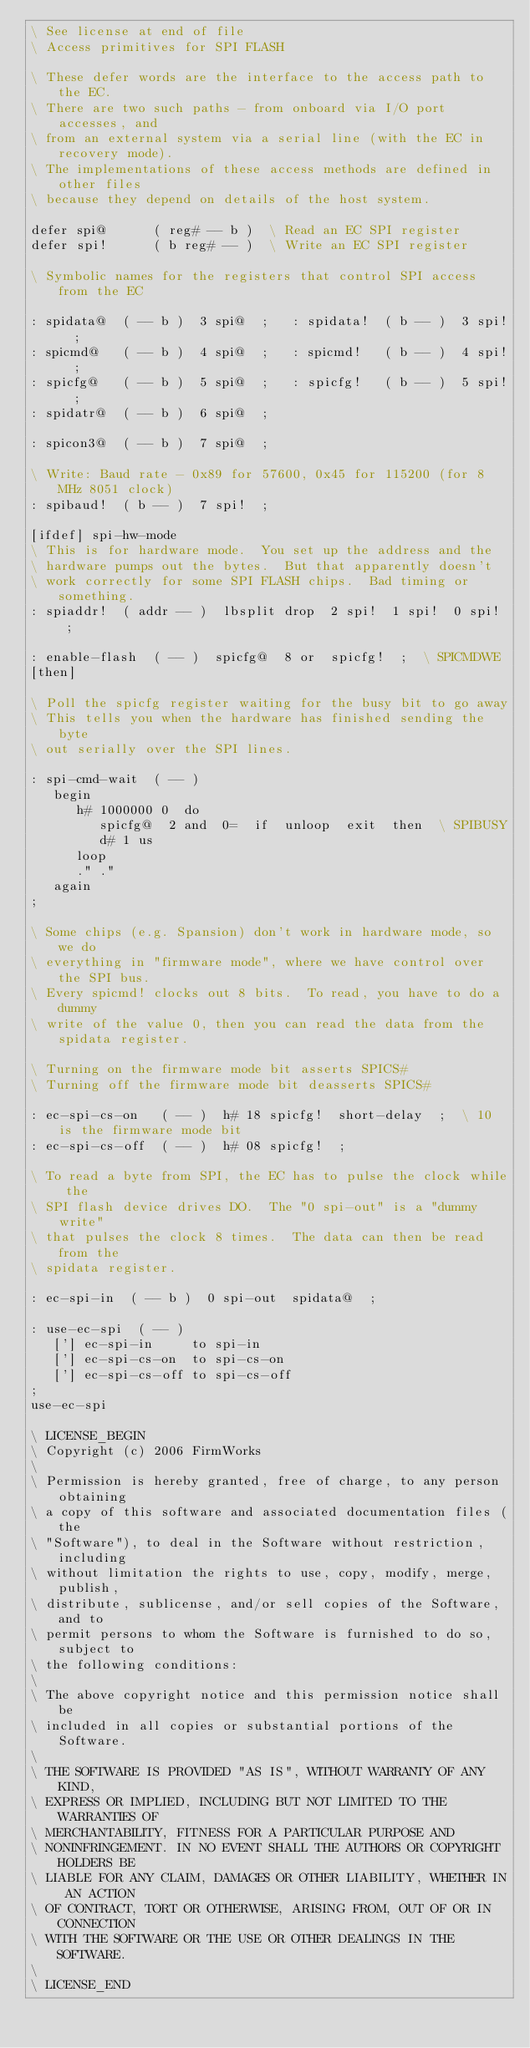<code> <loc_0><loc_0><loc_500><loc_500><_Forth_>\ See license at end of file
\ Access primitives for SPI FLASH

\ These defer words are the interface to the access path to the EC.
\ There are two such paths - from onboard via I/O port accesses, and
\ from an external system via a serial line (with the EC in recovery mode).
\ The implementations of these access methods are defined in other files
\ because they depend on details of the host system.

defer spi@      ( reg# -- b )  \ Read an EC SPI register
defer spi!      ( b reg# -- )  \ Write an EC SPI register

\ Symbolic names for the registers that control SPI access from the EC

: spidata@  ( -- b )  3 spi@  ;   : spidata!  ( b -- )  3 spi!  ;
: spicmd@   ( -- b )  4 spi@  ;   : spicmd!   ( b -- )  4 spi!  ;
: spicfg@   ( -- b )  5 spi@  ;   : spicfg!   ( b -- )  5 spi!  ;
: spidatr@  ( -- b )  6 spi@  ;

: spicon3@  ( -- b )  7 spi@  ;

\ Write: Baud rate - 0x89 for 57600, 0x45 for 115200 (for 8 MHz 8051 clock)
: spibaud!  ( b -- )  7 spi!  ;

[ifdef] spi-hw-mode
\ This is for hardware mode.  You set up the address and the
\ hardware pumps out the bytes.  But that apparently doesn't
\ work correctly for some SPI FLASH chips.  Bad timing or something.
: spiaddr!  ( addr -- )  lbsplit drop  2 spi!  1 spi!  0 spi!  ;

: enable-flash  ( -- )  spicfg@  8 or  spicfg!  ;  \ SPICMDWE
[then]

\ Poll the spicfg register waiting for the busy bit to go away
\ This tells you when the hardware has finished sending the byte
\ out serially over the SPI lines.

: spi-cmd-wait  ( -- )
   begin
      h# 1000000 0  do
         spicfg@  2 and  0=  if  unloop  exit  then  \ SPIBUSY
         d# 1 us
      loop
      ." ."
   again
;

\ Some chips (e.g. Spansion) don't work in hardware mode, so we do
\ everything in "firmware mode", where we have control over the SPI bus.
\ Every spicmd! clocks out 8 bits.  To read, you have to do a dummy
\ write of the value 0, then you can read the data from the spidata register.

\ Turning on the firmware mode bit asserts SPICS#
\ Turning off the firmware mode bit deasserts SPICS#

: ec-spi-cs-on   ( -- )  h# 18 spicfg!  short-delay  ;  \ 10 is the firmware mode bit
: ec-spi-cs-off  ( -- )  h# 08 spicfg!  ;

\ To read a byte from SPI, the EC has to pulse the clock while the
\ SPI flash device drives DO.  The "0 spi-out" is a "dummy write"
\ that pulses the clock 8 times.  The data can then be read from the
\ spidata register.

: ec-spi-in  ( -- b )  0 spi-out  spidata@  ;

: use-ec-spi  ( -- )
   ['] ec-spi-in     to spi-in
   ['] ec-spi-cs-on  to spi-cs-on
   ['] ec-spi-cs-off to spi-cs-off
;
use-ec-spi

\ LICENSE_BEGIN
\ Copyright (c) 2006 FirmWorks
\ 
\ Permission is hereby granted, free of charge, to any person obtaining
\ a copy of this software and associated documentation files (the
\ "Software"), to deal in the Software without restriction, including
\ without limitation the rights to use, copy, modify, merge, publish,
\ distribute, sublicense, and/or sell copies of the Software, and to
\ permit persons to whom the Software is furnished to do so, subject to
\ the following conditions:
\ 
\ The above copyright notice and this permission notice shall be
\ included in all copies or substantial portions of the Software.
\ 
\ THE SOFTWARE IS PROVIDED "AS IS", WITHOUT WARRANTY OF ANY KIND,
\ EXPRESS OR IMPLIED, INCLUDING BUT NOT LIMITED TO THE WARRANTIES OF
\ MERCHANTABILITY, FITNESS FOR A PARTICULAR PURPOSE AND
\ NONINFRINGEMENT. IN NO EVENT SHALL THE AUTHORS OR COPYRIGHT HOLDERS BE
\ LIABLE FOR ANY CLAIM, DAMAGES OR OTHER LIABILITY, WHETHER IN AN ACTION
\ OF CONTRACT, TORT OR OTHERWISE, ARISING FROM, OUT OF OR IN CONNECTION
\ WITH THE SOFTWARE OR THE USE OR OTHER DEALINGS IN THE SOFTWARE.
\
\ LICENSE_END
</code> 